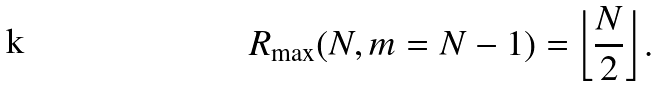<formula> <loc_0><loc_0><loc_500><loc_500>R _ { \max } ( N , m = N - 1 ) = \left \lfloor \frac { N } { 2 } \right \rfloor .</formula> 